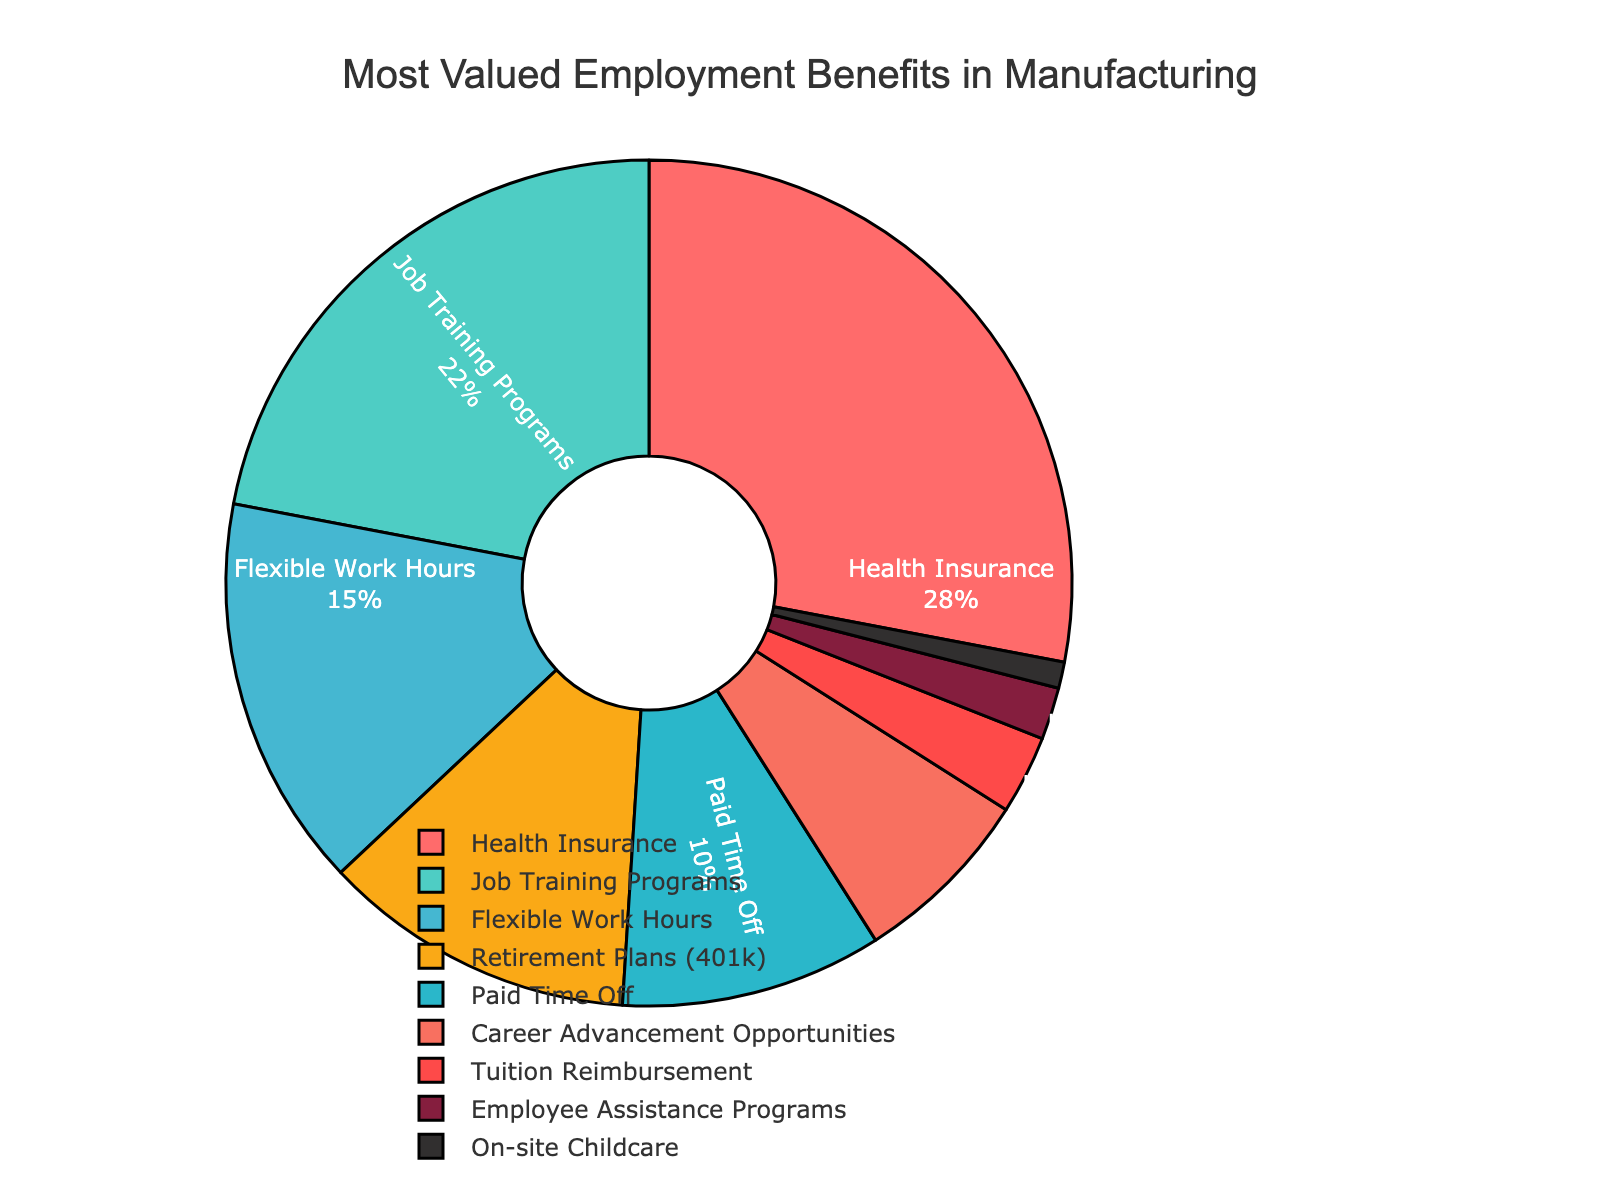Which employment benefit is most valued by job seekers in the manufacturing industry? The pie chart shows the distribution of various employment benefits valued by job seekers. The benefit with the largest percentage is Health Insurance at 28%.
Answer: Health Insurance How much percentage more is Health Insurance valued compared to Tuition Reimbursement? Health Insurance is valued at 28% and Tuition Reimbursement at 3%. The difference is calculated as 28% - 3% = 25%.
Answer: 25% What percentage of job seekers value Paid Time Off and Flexible Work Hours combined? According to the pie chart, Paid Time Off is valued at 10% and Flexible Work Hours at 15%. Adding these percentages gives 10% + 15% = 25%.
Answer: 25% Among the benefits valued by the job seekers, which one has the smallest percentage? The pie chart shows the distribution of employment benefits, and the smallest segment is On-site Childcare, valued at 1%.
Answer: On-site Childcare Is the percentage of job seekers who value Career Advancement Opportunities greater than those who value Job Training Programs? The pie chart indicates that Career Advancement Opportunities is valued at 7%, whereas Job Training Programs are at 22%. Since 7% is less than 22%, the statement is false.
Answer: No What is the total percentage of job seekers who value Health Insurance, Retirement Plans (401k), and Employee Assistance Programs combined? Health Insurance is 28%, Retirement Plans (401k) is 12%, and Employee Assistance Programs is 2%. Adding these gives 28% + 12% + 2% = 42%.
Answer: 42% How does the percentage of job seekers valuing Paid Time Off compare to those valuing Career Advancement Opportunities? Paid Time Off is valued at 10%, while Career Advancement Opportunities is at 7%. Since 10% is greater than 7%, Paid Time Off is more valued.
Answer: Paid Time Off Which benefit has a larger percentage: Tuition Reimbursement or On-site Childcare? According to the pie chart, Tuition Reimbursement is valued at 3%, and On-site Childcare at 1%. Thus, Tuition Reimbursement has a larger percentage.
Answer: Tuition Reimbursement What proportion of job seekers value Employee Assistance Programs relative to Job Training Programs? The pie chart shows Employee Assistance Programs at 2% and Job Training Programs at 22%. The proportion is calculated as 2% / 22%, which simplifies to approximately 0.0909 or 9.09%.
Answer: 9.09% What percentage of the total is accounted for by the three least valued benefits? The three least valued benefits are On-site Childcare (1%), Employee Assistance Programs (2%), and Tuition Reimbursement (3%). Adding these gives 1% + 2% + 3% = 6%.
Answer: 6% 